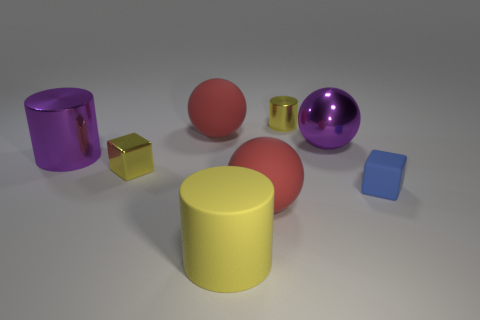Add 1 large red matte spheres. How many objects exist? 9 Subtract all balls. How many objects are left? 5 Add 6 big yellow matte objects. How many big yellow matte objects exist? 7 Subtract 0 cyan balls. How many objects are left? 8 Subtract all big cyan balls. Subtract all large yellow cylinders. How many objects are left? 7 Add 8 large purple objects. How many large purple objects are left? 10 